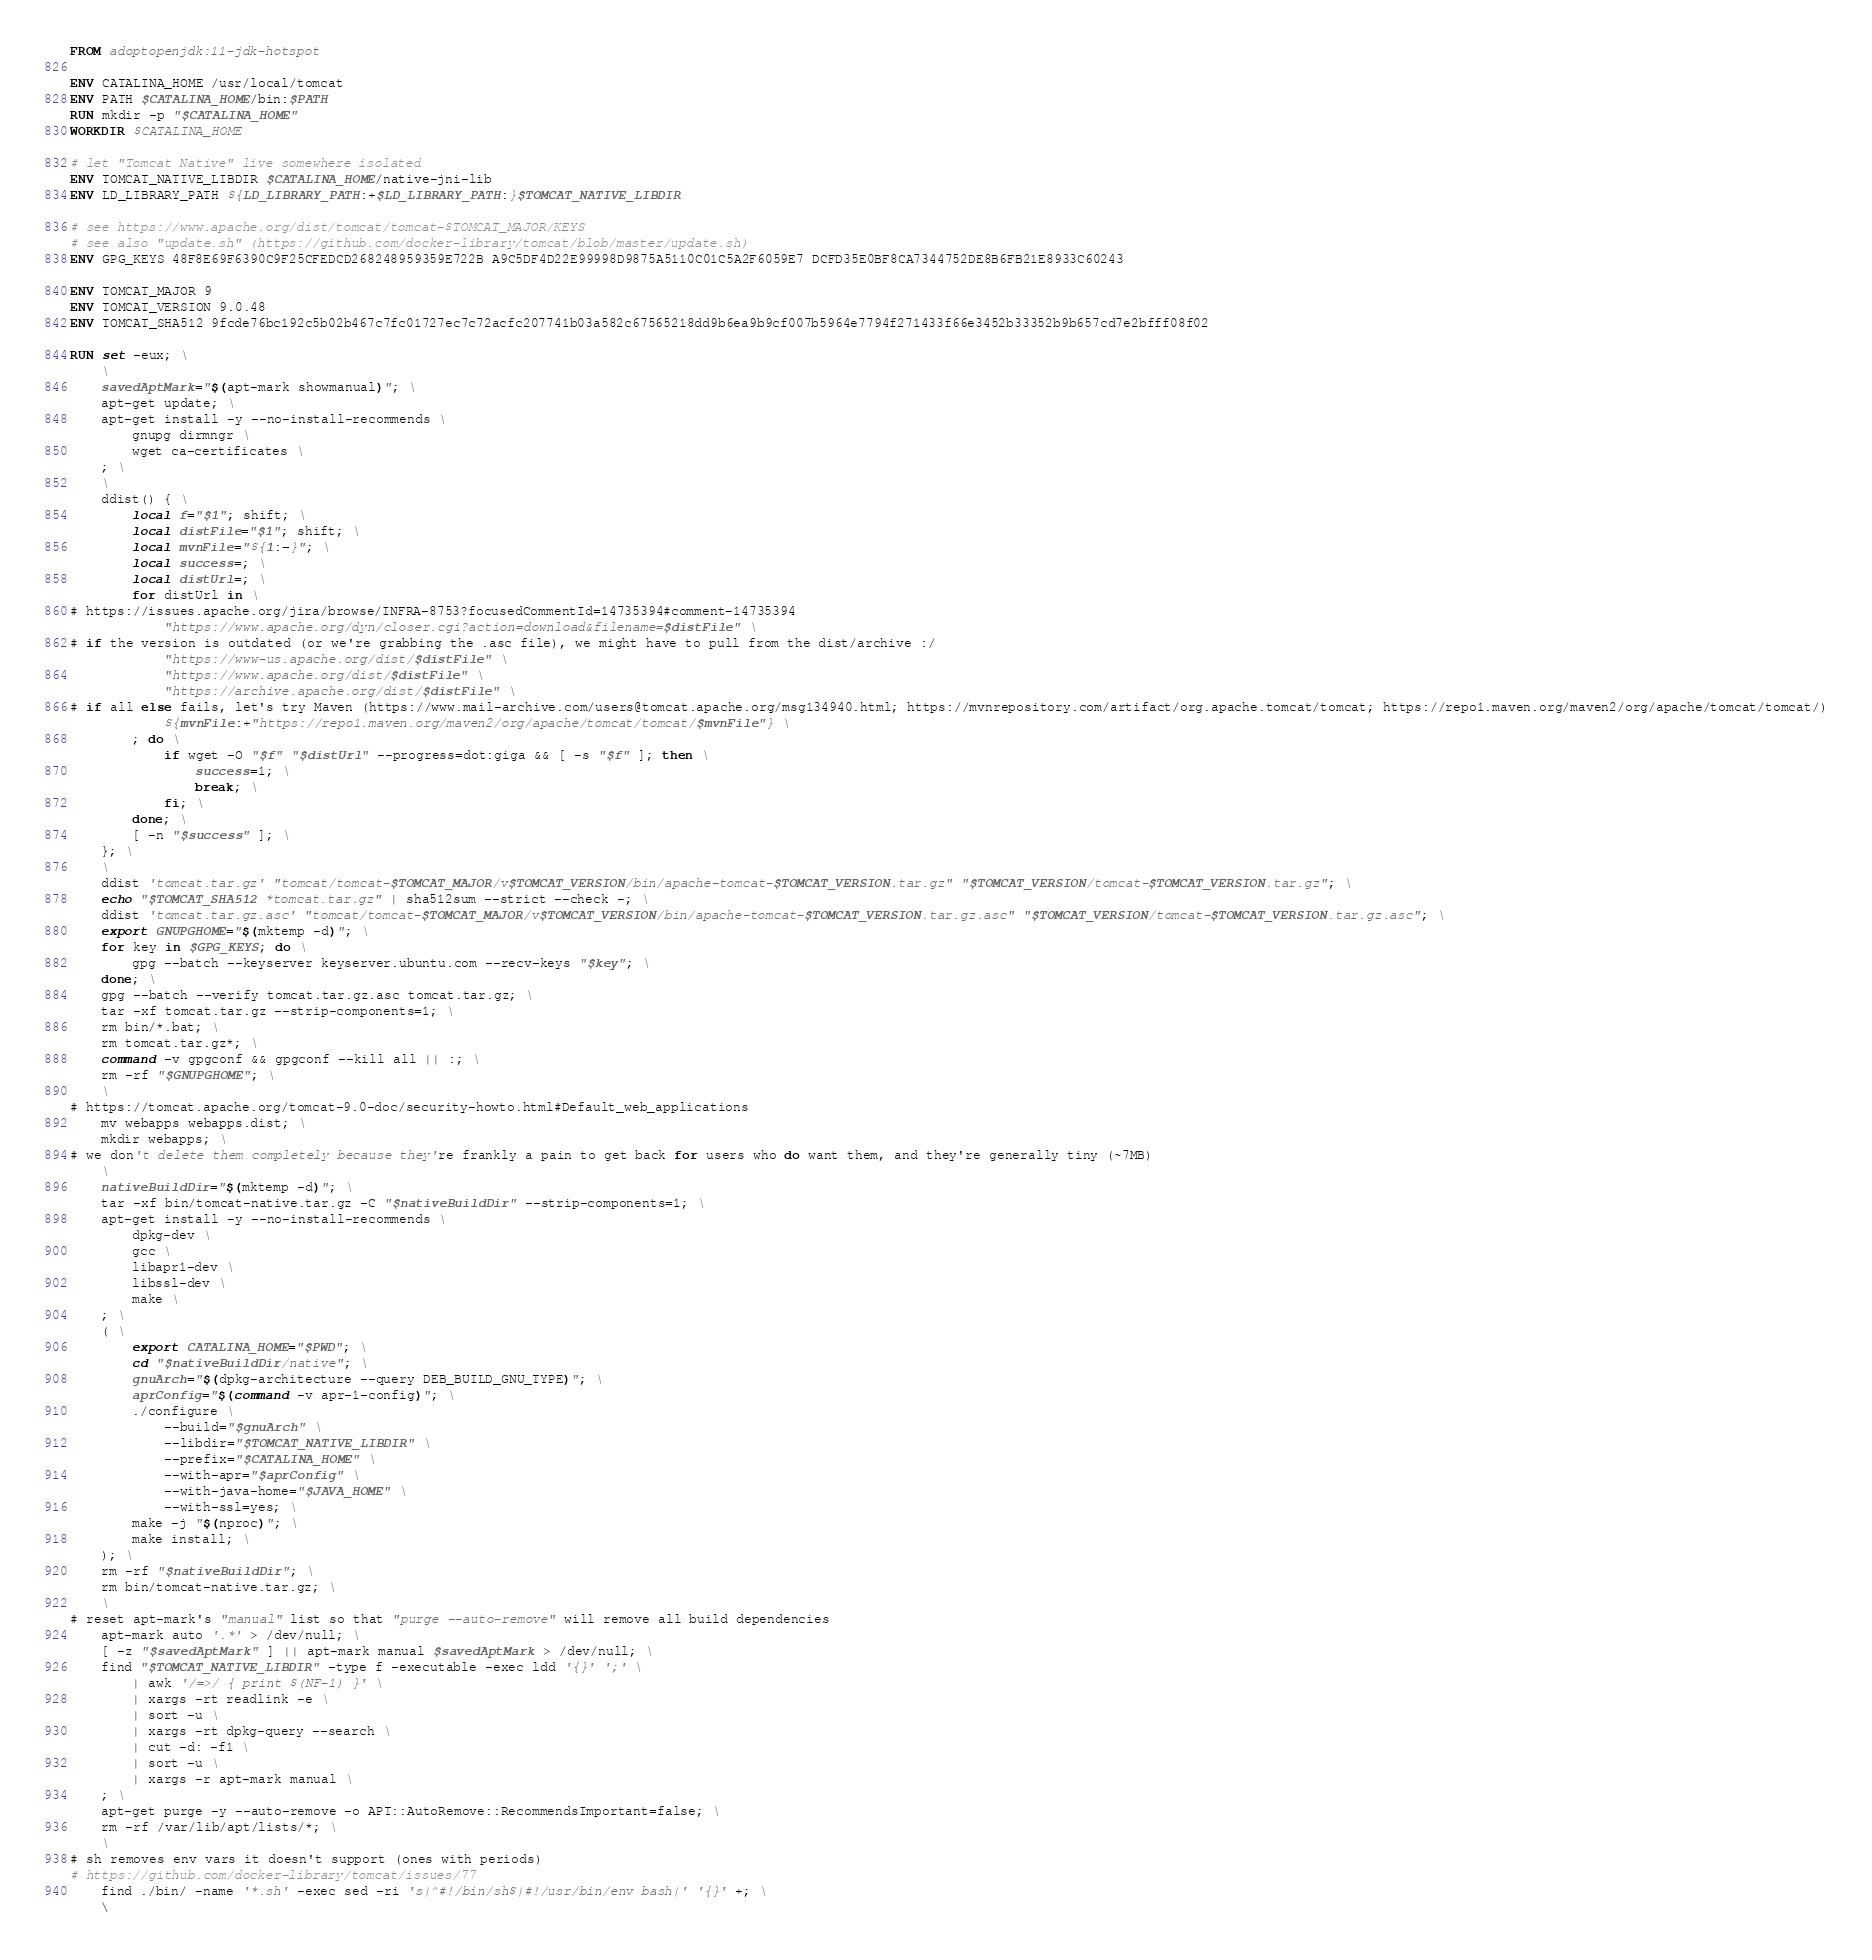<code> <loc_0><loc_0><loc_500><loc_500><_Dockerfile_>FROM adoptopenjdk:11-jdk-hotspot

ENV CATALINA_HOME /usr/local/tomcat
ENV PATH $CATALINA_HOME/bin:$PATH
RUN mkdir -p "$CATALINA_HOME"
WORKDIR $CATALINA_HOME

# let "Tomcat Native" live somewhere isolated
ENV TOMCAT_NATIVE_LIBDIR $CATALINA_HOME/native-jni-lib
ENV LD_LIBRARY_PATH ${LD_LIBRARY_PATH:+$LD_LIBRARY_PATH:}$TOMCAT_NATIVE_LIBDIR

# see https://www.apache.org/dist/tomcat/tomcat-$TOMCAT_MAJOR/KEYS
# see also "update.sh" (https://github.com/docker-library/tomcat/blob/master/update.sh)
ENV GPG_KEYS 48F8E69F6390C9F25CFEDCD268248959359E722B A9C5DF4D22E99998D9875A5110C01C5A2F6059E7 DCFD35E0BF8CA7344752DE8B6FB21E8933C60243

ENV TOMCAT_MAJOR 9
ENV TOMCAT_VERSION 9.0.48
ENV TOMCAT_SHA512 9fcde76bc192c5b02b467c7fc01727ec7c72acfc207741b03a582c67565218dd9b6ea9b9cf007b5964e7794f271433f66e3452b33352b9b657cd7e2bfff08f02

RUN set -eux; \
	\
	savedAptMark="$(apt-mark showmanual)"; \
	apt-get update; \
	apt-get install -y --no-install-recommends \
		gnupg dirmngr \
		wget ca-certificates \
	; \
	\
	ddist() { \
		local f="$1"; shift; \
		local distFile="$1"; shift; \
		local mvnFile="${1:-}"; \
		local success=; \
		local distUrl=; \
		for distUrl in \
# https://issues.apache.org/jira/browse/INFRA-8753?focusedCommentId=14735394#comment-14735394
			"https://www.apache.org/dyn/closer.cgi?action=download&filename=$distFile" \
# if the version is outdated (or we're grabbing the .asc file), we might have to pull from the dist/archive :/
			"https://www-us.apache.org/dist/$distFile" \
			"https://www.apache.org/dist/$distFile" \
			"https://archive.apache.org/dist/$distFile" \
# if all else fails, let's try Maven (https://www.mail-archive.com/users@tomcat.apache.org/msg134940.html; https://mvnrepository.com/artifact/org.apache.tomcat/tomcat; https://repo1.maven.org/maven2/org/apache/tomcat/tomcat/)
			${mvnFile:+"https://repo1.maven.org/maven2/org/apache/tomcat/tomcat/$mvnFile"} \
		; do \
			if wget -O "$f" "$distUrl" --progress=dot:giga && [ -s "$f" ]; then \
				success=1; \
				break; \
			fi; \
		done; \
		[ -n "$success" ]; \
	}; \
	\
	ddist 'tomcat.tar.gz' "tomcat/tomcat-$TOMCAT_MAJOR/v$TOMCAT_VERSION/bin/apache-tomcat-$TOMCAT_VERSION.tar.gz" "$TOMCAT_VERSION/tomcat-$TOMCAT_VERSION.tar.gz"; \
	echo "$TOMCAT_SHA512 *tomcat.tar.gz" | sha512sum --strict --check -; \
	ddist 'tomcat.tar.gz.asc' "tomcat/tomcat-$TOMCAT_MAJOR/v$TOMCAT_VERSION/bin/apache-tomcat-$TOMCAT_VERSION.tar.gz.asc" "$TOMCAT_VERSION/tomcat-$TOMCAT_VERSION.tar.gz.asc"; \
	export GNUPGHOME="$(mktemp -d)"; \
	for key in $GPG_KEYS; do \
		gpg --batch --keyserver keyserver.ubuntu.com --recv-keys "$key"; \
	done; \
	gpg --batch --verify tomcat.tar.gz.asc tomcat.tar.gz; \
	tar -xf tomcat.tar.gz --strip-components=1; \
	rm bin/*.bat; \
	rm tomcat.tar.gz*; \
	command -v gpgconf && gpgconf --kill all || :; \
	rm -rf "$GNUPGHOME"; \
	\
# https://tomcat.apache.org/tomcat-9.0-doc/security-howto.html#Default_web_applications
	mv webapps webapps.dist; \
	mkdir webapps; \
# we don't delete them completely because they're frankly a pain to get back for users who do want them, and they're generally tiny (~7MB)
	\
	nativeBuildDir="$(mktemp -d)"; \
	tar -xf bin/tomcat-native.tar.gz -C "$nativeBuildDir" --strip-components=1; \
	apt-get install -y --no-install-recommends \
		dpkg-dev \
		gcc \
		libapr1-dev \
		libssl-dev \
		make \
	; \
	( \
		export CATALINA_HOME="$PWD"; \
		cd "$nativeBuildDir/native"; \
		gnuArch="$(dpkg-architecture --query DEB_BUILD_GNU_TYPE)"; \
		aprConfig="$(command -v apr-1-config)"; \
		./configure \
			--build="$gnuArch" \
			--libdir="$TOMCAT_NATIVE_LIBDIR" \
			--prefix="$CATALINA_HOME" \
			--with-apr="$aprConfig" \
			--with-java-home="$JAVA_HOME" \
			--with-ssl=yes; \
		make -j "$(nproc)"; \
		make install; \
	); \
	rm -rf "$nativeBuildDir"; \
	rm bin/tomcat-native.tar.gz; \
	\
# reset apt-mark's "manual" list so that "purge --auto-remove" will remove all build dependencies
	apt-mark auto '.*' > /dev/null; \
	[ -z "$savedAptMark" ] || apt-mark manual $savedAptMark > /dev/null; \
	find "$TOMCAT_NATIVE_LIBDIR" -type f -executable -exec ldd '{}' ';' \
		| awk '/=>/ { print $(NF-1) }' \
		| xargs -rt readlink -e \
		| sort -u \
		| xargs -rt dpkg-query --search \
		| cut -d: -f1 \
		| sort -u \
		| xargs -r apt-mark manual \
	; \
	apt-get purge -y --auto-remove -o APT::AutoRemove::RecommendsImportant=false; \
	rm -rf /var/lib/apt/lists/*; \
	\
# sh removes env vars it doesn't support (ones with periods)
# https://github.com/docker-library/tomcat/issues/77
	find ./bin/ -name '*.sh' -exec sed -ri 's|^#!/bin/sh$|#!/usr/bin/env bash|' '{}' +; \
	\</code> 